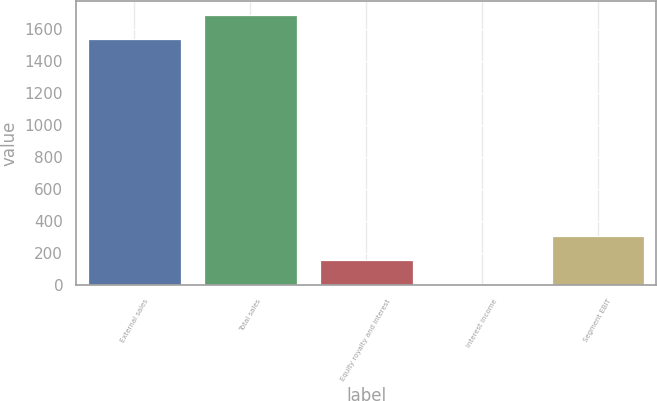Convert chart to OTSL. <chart><loc_0><loc_0><loc_500><loc_500><bar_chart><fcel>External sales<fcel>Total sales<fcel>Equity royalty and interest<fcel>Interest income<fcel>Segment EBIT<nl><fcel>1537<fcel>1690.9<fcel>154.9<fcel>1<fcel>308.8<nl></chart> 